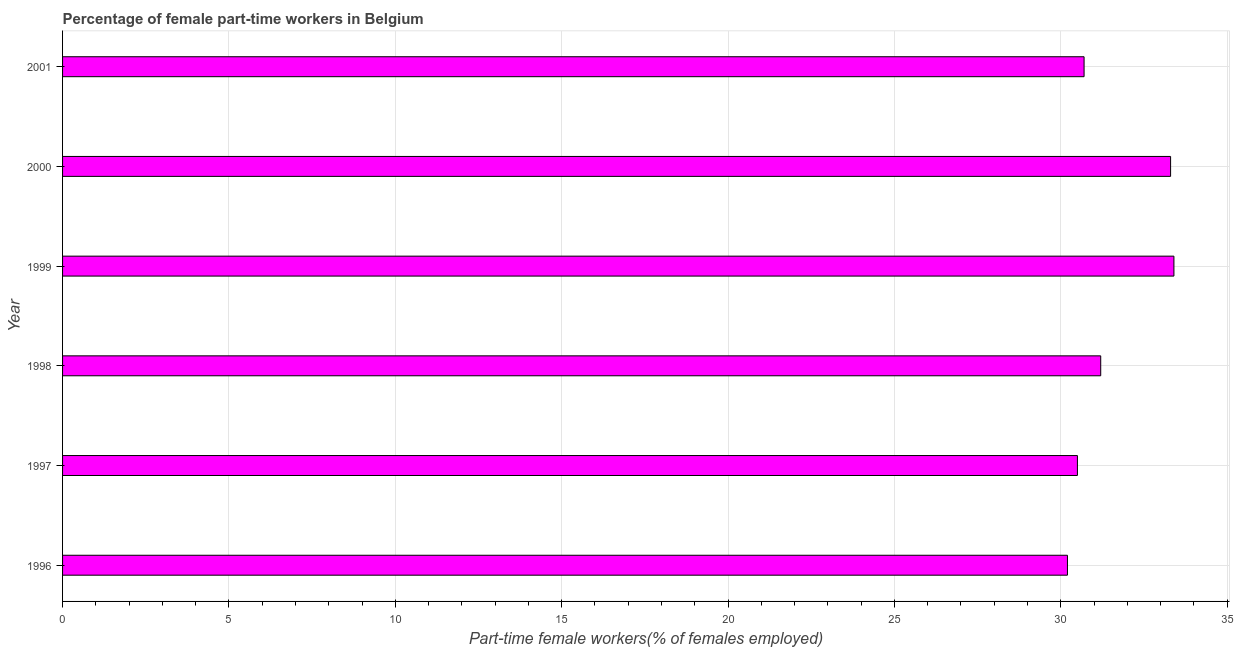What is the title of the graph?
Give a very brief answer. Percentage of female part-time workers in Belgium. What is the label or title of the X-axis?
Provide a short and direct response. Part-time female workers(% of females employed). What is the percentage of part-time female workers in 1999?
Provide a short and direct response. 33.4. Across all years, what is the maximum percentage of part-time female workers?
Provide a succinct answer. 33.4. Across all years, what is the minimum percentage of part-time female workers?
Give a very brief answer. 30.2. In which year was the percentage of part-time female workers maximum?
Ensure brevity in your answer.  1999. In which year was the percentage of part-time female workers minimum?
Your answer should be very brief. 1996. What is the sum of the percentage of part-time female workers?
Give a very brief answer. 189.3. What is the difference between the percentage of part-time female workers in 1998 and 2001?
Your answer should be very brief. 0.5. What is the average percentage of part-time female workers per year?
Provide a succinct answer. 31.55. What is the median percentage of part-time female workers?
Your response must be concise. 30.95. Do a majority of the years between 1998 and 2000 (inclusive) have percentage of part-time female workers greater than 30 %?
Offer a terse response. Yes. Is the percentage of part-time female workers in 1997 less than that in 1999?
Your answer should be compact. Yes. Is the difference between the percentage of part-time female workers in 1996 and 1999 greater than the difference between any two years?
Make the answer very short. Yes. What is the difference between the highest and the lowest percentage of part-time female workers?
Ensure brevity in your answer.  3.2. In how many years, is the percentage of part-time female workers greater than the average percentage of part-time female workers taken over all years?
Offer a terse response. 2. How many bars are there?
Provide a short and direct response. 6. What is the difference between two consecutive major ticks on the X-axis?
Keep it short and to the point. 5. Are the values on the major ticks of X-axis written in scientific E-notation?
Keep it short and to the point. No. What is the Part-time female workers(% of females employed) of 1996?
Your response must be concise. 30.2. What is the Part-time female workers(% of females employed) of 1997?
Provide a short and direct response. 30.5. What is the Part-time female workers(% of females employed) of 1998?
Provide a short and direct response. 31.2. What is the Part-time female workers(% of females employed) in 1999?
Make the answer very short. 33.4. What is the Part-time female workers(% of females employed) of 2000?
Provide a succinct answer. 33.3. What is the Part-time female workers(% of females employed) in 2001?
Your answer should be very brief. 30.7. What is the difference between the Part-time female workers(% of females employed) in 1996 and 2000?
Keep it short and to the point. -3.1. What is the difference between the Part-time female workers(% of females employed) in 1997 and 1998?
Keep it short and to the point. -0.7. What is the difference between the Part-time female workers(% of females employed) in 1997 and 2000?
Ensure brevity in your answer.  -2.8. What is the difference between the Part-time female workers(% of females employed) in 1998 and 1999?
Offer a terse response. -2.2. What is the difference between the Part-time female workers(% of females employed) in 1998 and 2000?
Make the answer very short. -2.1. What is the difference between the Part-time female workers(% of females employed) in 2000 and 2001?
Make the answer very short. 2.6. What is the ratio of the Part-time female workers(% of females employed) in 1996 to that in 1997?
Ensure brevity in your answer.  0.99. What is the ratio of the Part-time female workers(% of females employed) in 1996 to that in 1998?
Offer a terse response. 0.97. What is the ratio of the Part-time female workers(% of females employed) in 1996 to that in 1999?
Provide a short and direct response. 0.9. What is the ratio of the Part-time female workers(% of females employed) in 1996 to that in 2000?
Ensure brevity in your answer.  0.91. What is the ratio of the Part-time female workers(% of females employed) in 1997 to that in 1998?
Provide a short and direct response. 0.98. What is the ratio of the Part-time female workers(% of females employed) in 1997 to that in 2000?
Offer a terse response. 0.92. What is the ratio of the Part-time female workers(% of females employed) in 1997 to that in 2001?
Offer a very short reply. 0.99. What is the ratio of the Part-time female workers(% of females employed) in 1998 to that in 1999?
Provide a short and direct response. 0.93. What is the ratio of the Part-time female workers(% of females employed) in 1998 to that in 2000?
Provide a short and direct response. 0.94. What is the ratio of the Part-time female workers(% of females employed) in 1998 to that in 2001?
Provide a succinct answer. 1.02. What is the ratio of the Part-time female workers(% of females employed) in 1999 to that in 2000?
Ensure brevity in your answer.  1. What is the ratio of the Part-time female workers(% of females employed) in 1999 to that in 2001?
Your answer should be very brief. 1.09. What is the ratio of the Part-time female workers(% of females employed) in 2000 to that in 2001?
Provide a succinct answer. 1.08. 